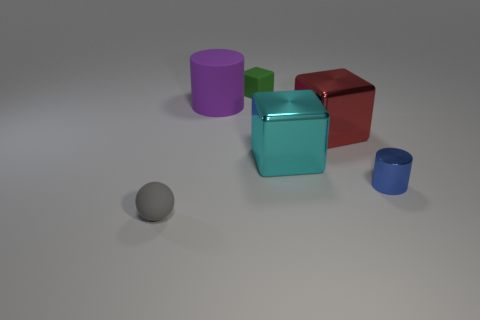How many objects are large metal blocks or balls?
Your answer should be compact. 3. Are there any yellow metallic things that have the same shape as the tiny blue object?
Your answer should be compact. No. Do the big metallic block that is to the left of the red object and the tiny cylinder have the same color?
Give a very brief answer. No. What shape is the tiny rubber thing on the left side of the tiny object behind the large purple matte cylinder?
Your response must be concise. Sphere. Is there a gray metal object that has the same size as the red shiny object?
Give a very brief answer. No. Is the number of small brown blocks less than the number of gray things?
Offer a very short reply. Yes. The tiny matte object that is behind the tiny matte object in front of the purple matte cylinder to the left of the large cyan shiny cube is what shape?
Your response must be concise. Cube. What number of things are matte things behind the ball or big blocks that are on the left side of the red metal object?
Offer a very short reply. 3. There is a tiny green rubber block; are there any cubes in front of it?
Ensure brevity in your answer.  Yes. How many objects are small objects on the left side of the big red block or tiny cylinders?
Keep it short and to the point. 3. 